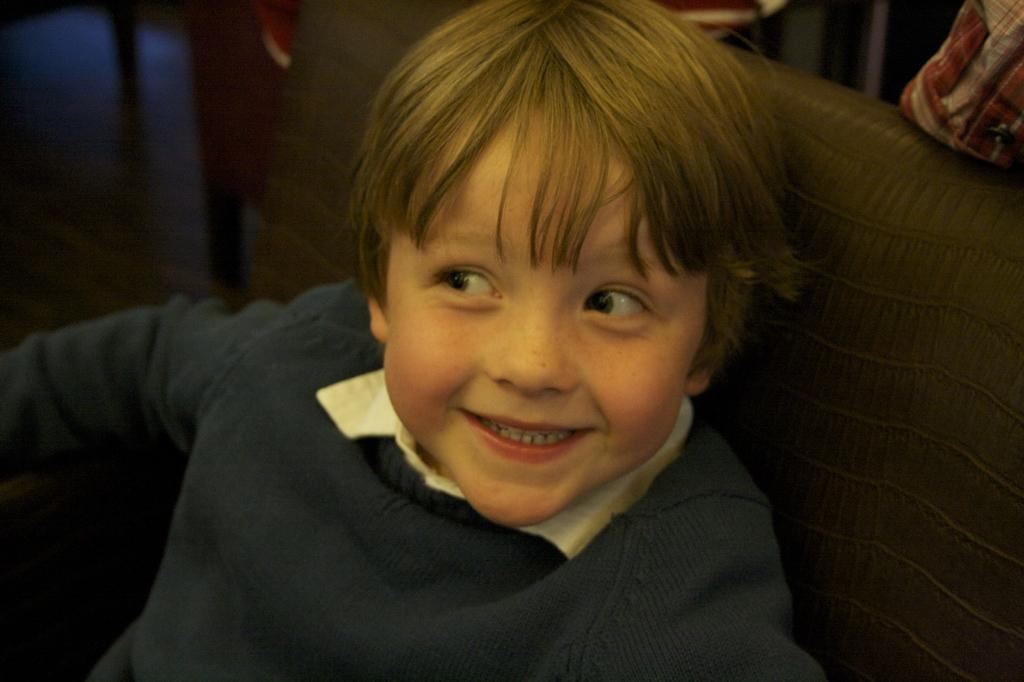What is the person in the image doing? The person is sitting on a chair in the image. What can be seen on the right side of the image? There are objects on the right side of the image. What is present on the left side of the image? There are chairs on the left side of the image. What type of friction is present between the person and the chair in the image? There is no information about friction between the person and the chair in the image. --- Facts: 1. There is a person holding a book in the image. 2. The person is standing near a bookshelf. 3. The bookshelf has multiple books on it. 4. There is a window in the background of the image. Absurd Topics: parrot, sand, volcano Conversation: What is the person holding in the image? The person is holding a book in the image. Where is the person standing in relation to the bookshelf? The person is standing near a bookshelf in the image. What can be seen on the bookshelf? The bookshelf has multiple books on it. What is visible in the background of the image? There is a window in the background of the image. Reasoning: Let's think step by step in order to produce the conversation. We start by identifying the main subject in the image, which is the person holding a book. Then, we expand the conversation to include other objects and elements in the image, such as the bookshelf, the books on the bookshelf, and the window in the background. Each question is designed to elicit a specific detail about the image that is known from the provided facts. Absurd Question/Answer: Can you tell me how many parrots are sitting on the bookshelf in the image? There are no parrots present on the bookshelf or in the image. 